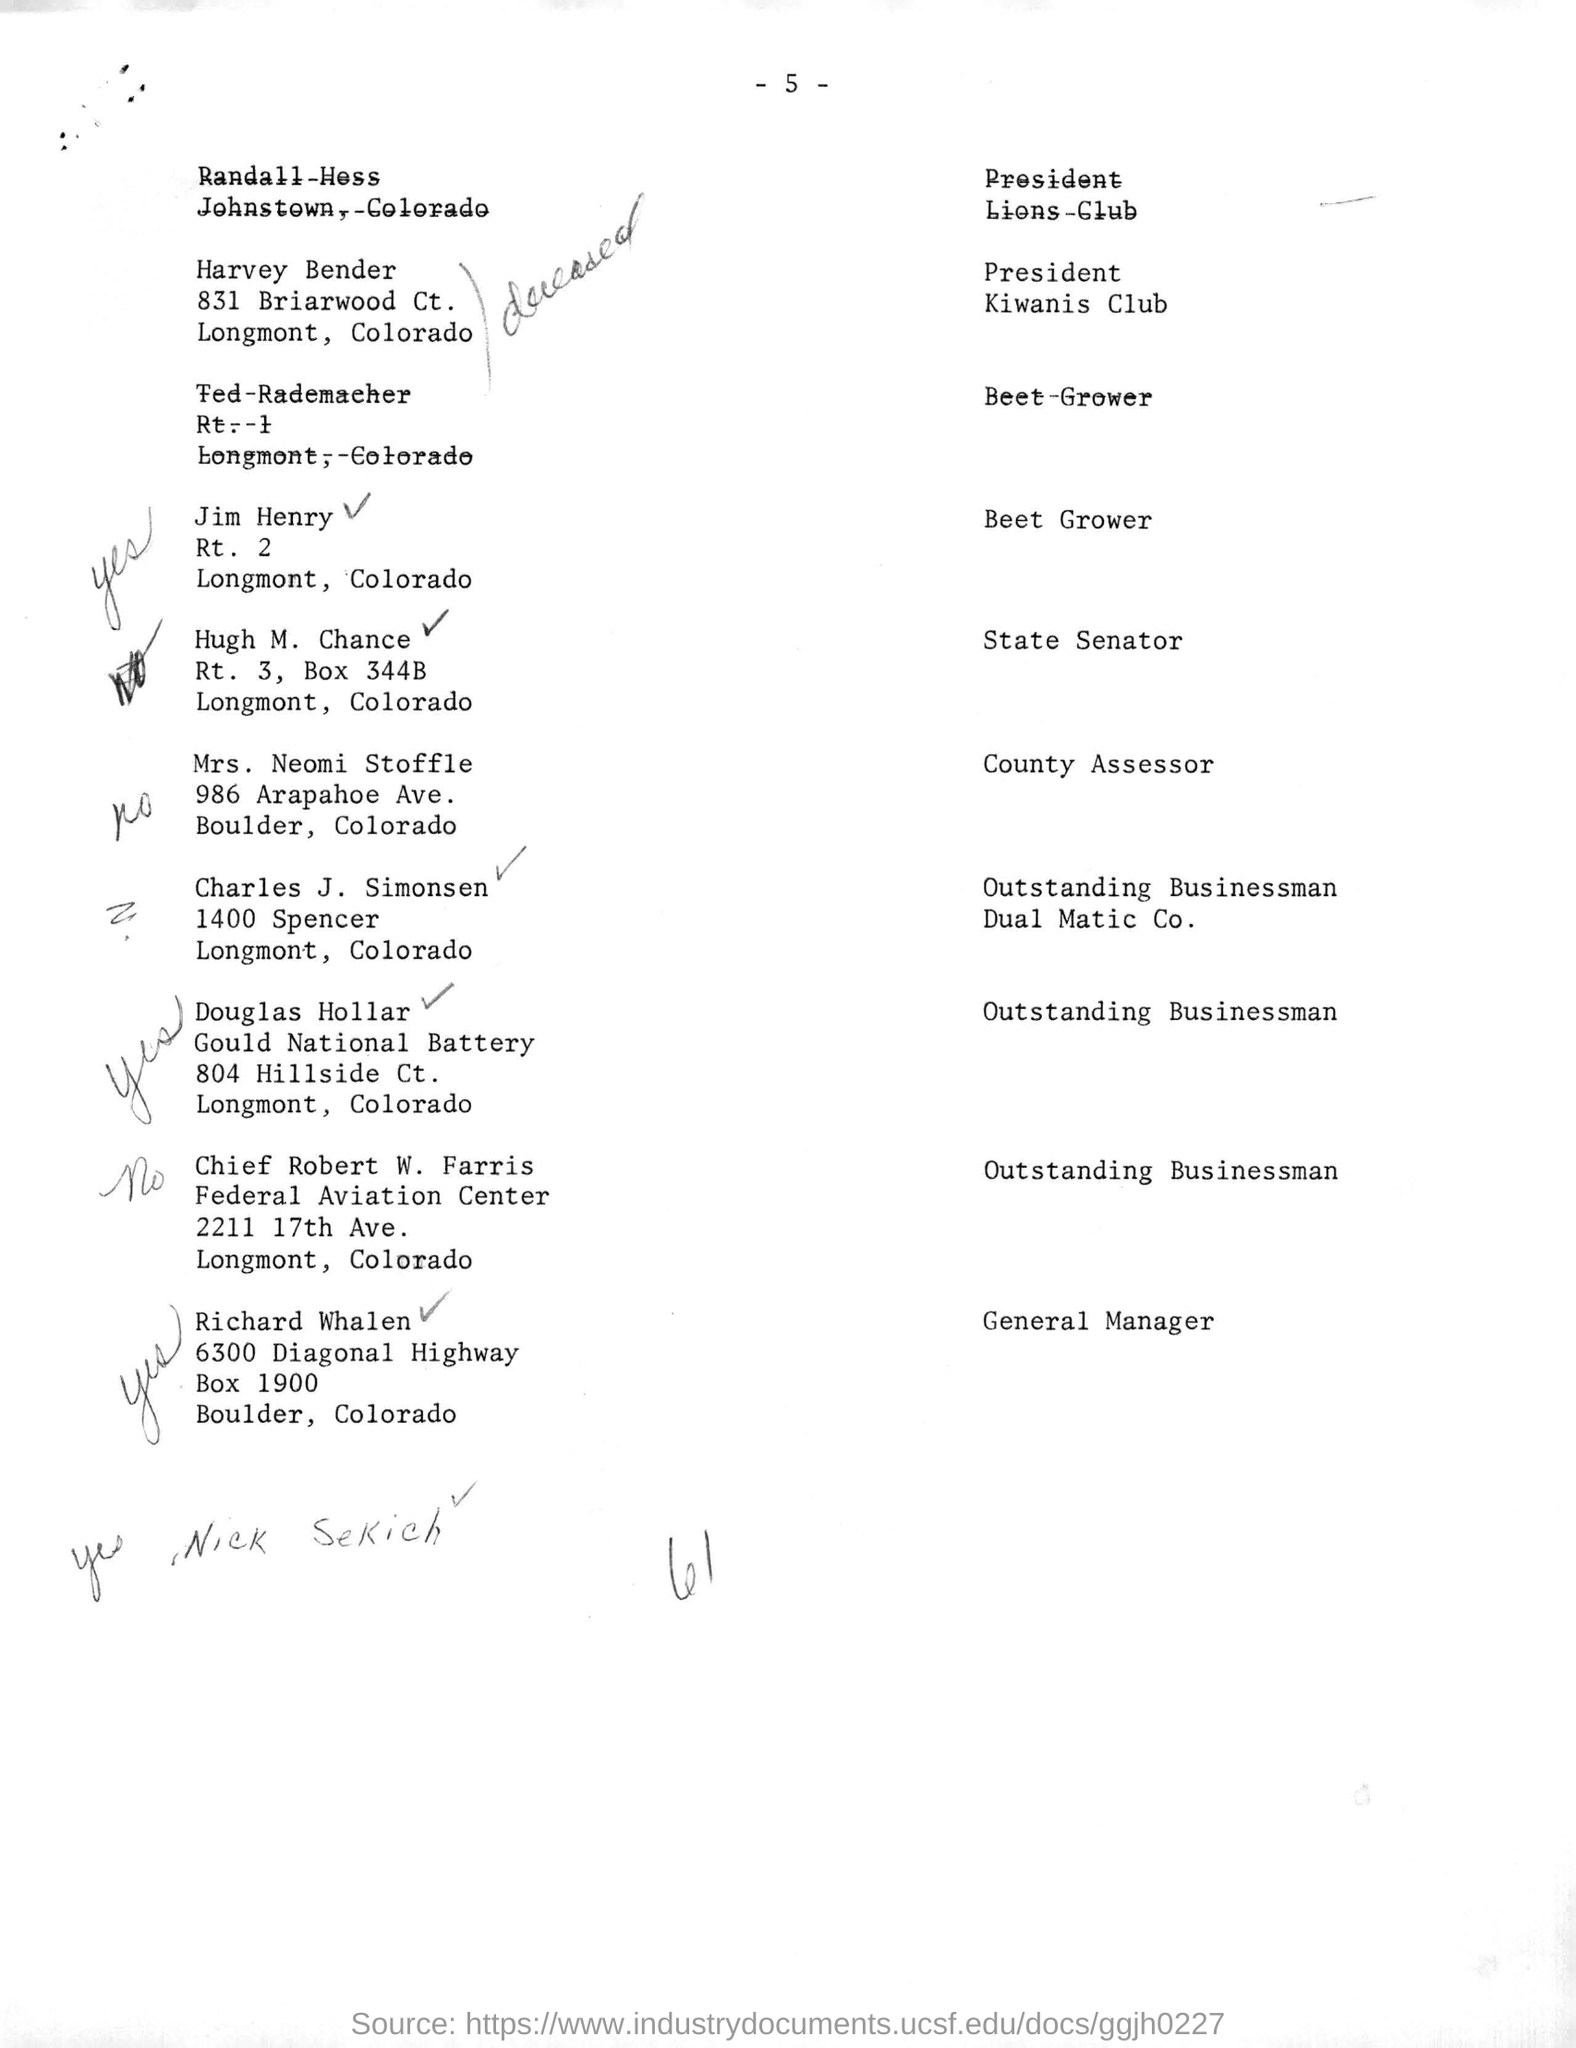What is the designation of harvey bender of kiwanis club ?
Make the answer very short. President. What is the designation of Hugh M. chance?
Ensure brevity in your answer.  State senator. In which avenue mrs. neomi stoffle are staying?
Keep it short and to the point. 986 arapahoe Ave. What is the designation of mrs. neomi stoffle?
Make the answer very short. County assessor. Who is called as outstanding businessman for "dual matic co".?
Provide a short and direct response. Charles J. simonsen. In which aviation center chief robert w. farris are working?
Ensure brevity in your answer.  Federal aviation center. What is the post box number of 6300 diagonal highway for boulder, colorado?
Ensure brevity in your answer.  1900. Who is designated as general manager ?
Offer a terse response. Richard whalen. 